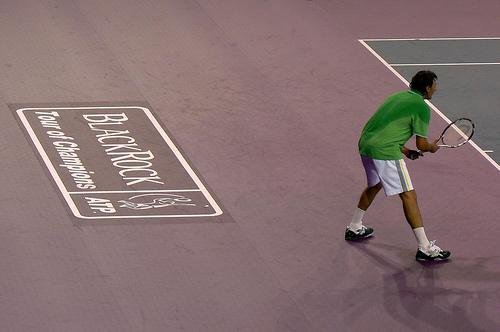What sport is being played?
Concise answer only. Tennis. What are the letters?
Quick response, please. Blackrock. What does the advertisement say?
Quick response, please. Blackrock tour of champions. What color is the shirt?
Short answer required. Green. What sport is this?
Be succinct. Tennis. Is this person a skilled athlete?
Give a very brief answer. Yes. What color is the ground?
Give a very brief answer. Brown. Did the man hit the ball?
Keep it brief. No. 